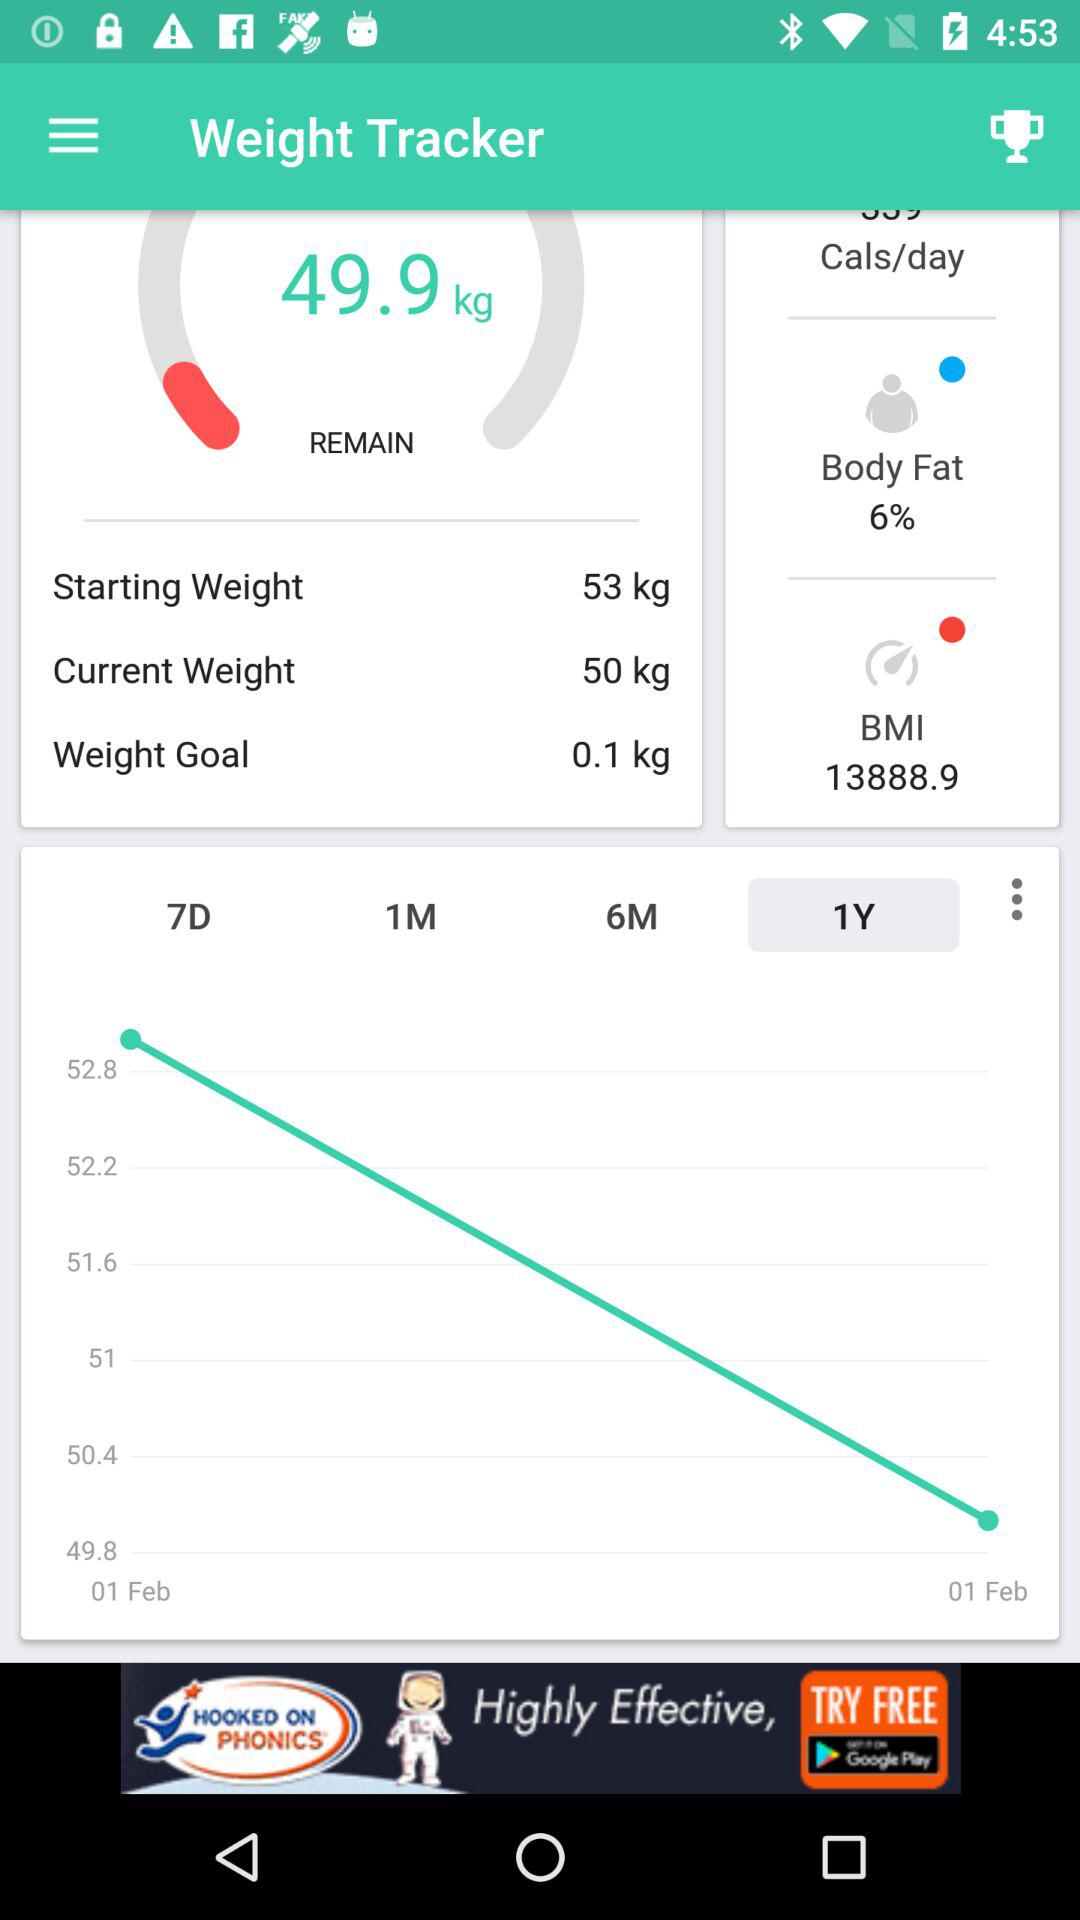What is the current weight? The current weight is 50 kg. 